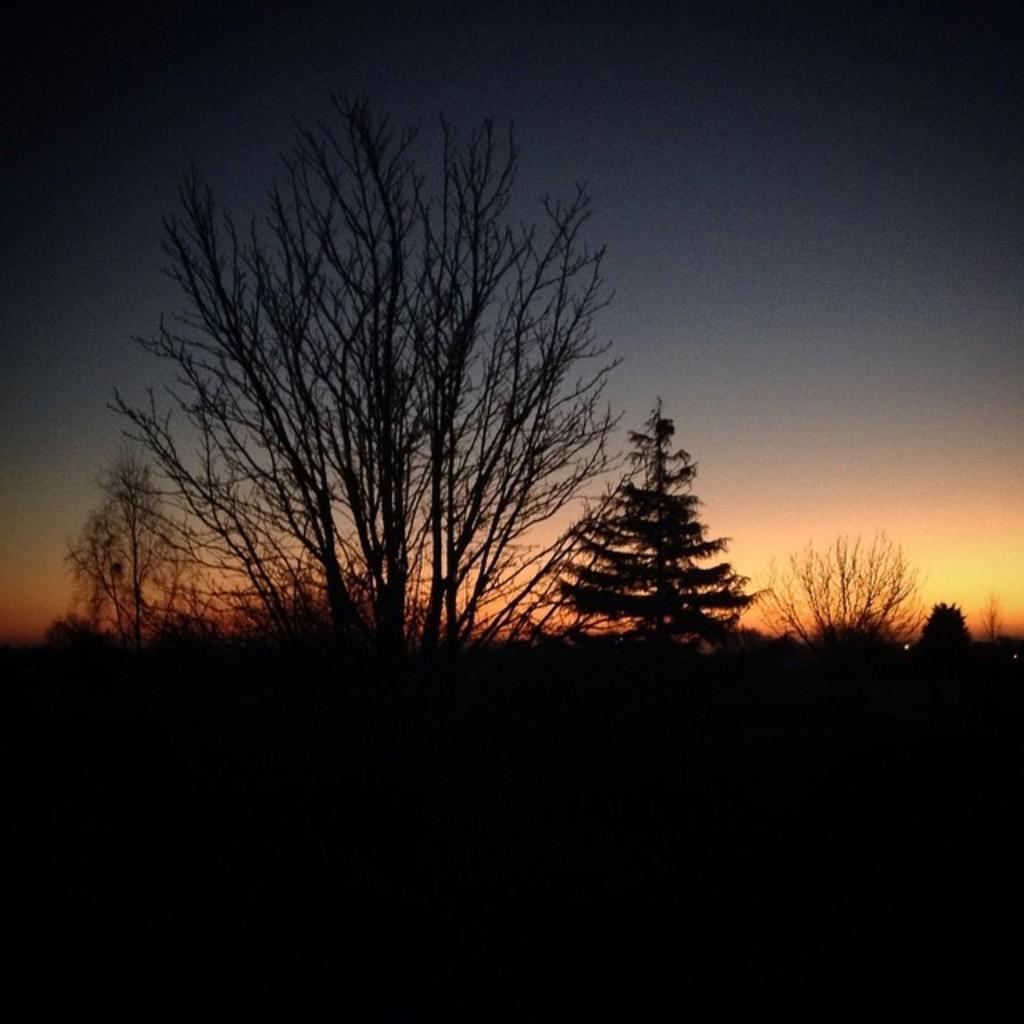Please provide a concise description of this image. There are trees in the foreground and sky in the background area, it seems to be the view of sunset. 